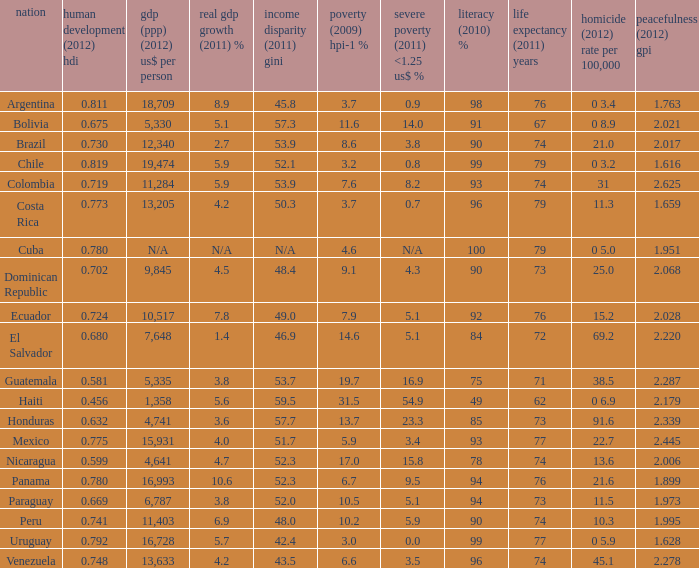What murder (2012) rate per 100,00 also has a 1.616 as the peace (2012) GPI? 0 3.2. I'm looking to parse the entire table for insights. Could you assist me with that? {'header': ['nation', 'human development (2012) hdi', 'gdp (ppp) (2012) us$ per person', 'real gdp growth (2011) %', 'income disparity (2011) gini', 'poverty (2009) hpi-1 %', 'severe poverty (2011) <1.25 us$ %', 'literacy (2010) %', 'life expectancy (2011) years', 'homicide (2012) rate per 100,000', 'peacefulness (2012) gpi'], 'rows': [['Argentina', '0.811', '18,709', '8.9', '45.8', '3.7', '0.9', '98', '76', '0 3.4', '1.763'], ['Bolivia', '0.675', '5,330', '5.1', '57.3', '11.6', '14.0', '91', '67', '0 8.9', '2.021'], ['Brazil', '0.730', '12,340', '2.7', '53.9', '8.6', '3.8', '90', '74', '21.0', '2.017'], ['Chile', '0.819', '19,474', '5.9', '52.1', '3.2', '0.8', '99', '79', '0 3.2', '1.616'], ['Colombia', '0.719', '11,284', '5.9', '53.9', '7.6', '8.2', '93', '74', '31', '2.625'], ['Costa Rica', '0.773', '13,205', '4.2', '50.3', '3.7', '0.7', '96', '79', '11.3', '1.659'], ['Cuba', '0.780', 'N/A', 'N/A', 'N/A', '4.6', 'N/A', '100', '79', '0 5.0', '1.951'], ['Dominican Republic', '0.702', '9,845', '4.5', '48.4', '9.1', '4.3', '90', '73', '25.0', '2.068'], ['Ecuador', '0.724', '10,517', '7.8', '49.0', '7.9', '5.1', '92', '76', '15.2', '2.028'], ['El Salvador', '0.680', '7,648', '1.4', '46.9', '14.6', '5.1', '84', '72', '69.2', '2.220'], ['Guatemala', '0.581', '5,335', '3.8', '53.7', '19.7', '16.9', '75', '71', '38.5', '2.287'], ['Haiti', '0.456', '1,358', '5.6', '59.5', '31.5', '54.9', '49', '62', '0 6.9', '2.179'], ['Honduras', '0.632', '4,741', '3.6', '57.7', '13.7', '23.3', '85', '73', '91.6', '2.339'], ['Mexico', '0.775', '15,931', '4.0', '51.7', '5.9', '3.4', '93', '77', '22.7', '2.445'], ['Nicaragua', '0.599', '4,641', '4.7', '52.3', '17.0', '15.8', '78', '74', '13.6', '2.006'], ['Panama', '0.780', '16,993', '10.6', '52.3', '6.7', '9.5', '94', '76', '21.6', '1.899'], ['Paraguay', '0.669', '6,787', '3.8', '52.0', '10.5', '5.1', '94', '73', '11.5', '1.973'], ['Peru', '0.741', '11,403', '6.9', '48.0', '10.2', '5.9', '90', '74', '10.3', '1.995'], ['Uruguay', '0.792', '16,728', '5.7', '42.4', '3.0', '0.0', '99', '77', '0 5.9', '1.628'], ['Venezuela', '0.748', '13,633', '4.2', '43.5', '6.6', '3.5', '96', '74', '45.1', '2.278']]} 